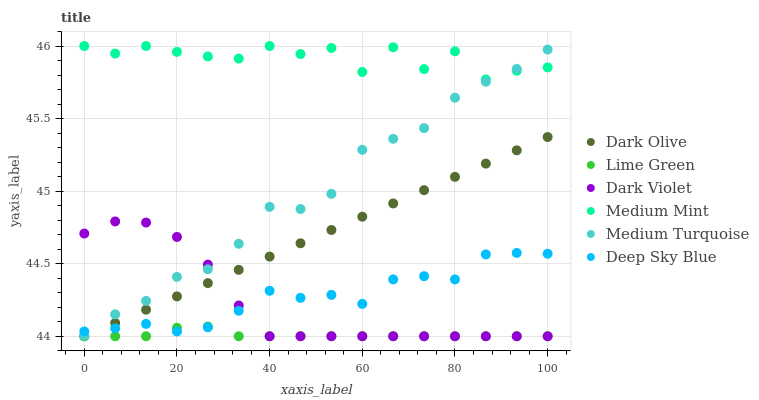Does Lime Green have the minimum area under the curve?
Answer yes or no. Yes. Does Medium Mint have the maximum area under the curve?
Answer yes or no. Yes. Does Medium Turquoise have the minimum area under the curve?
Answer yes or no. No. Does Medium Turquoise have the maximum area under the curve?
Answer yes or no. No. Is Dark Olive the smoothest?
Answer yes or no. Yes. Is Medium Mint the roughest?
Answer yes or no. Yes. Is Medium Turquoise the smoothest?
Answer yes or no. No. Is Medium Turquoise the roughest?
Answer yes or no. No. Does Dark Olive have the lowest value?
Answer yes or no. Yes. Does Medium Turquoise have the lowest value?
Answer yes or no. No. Does Medium Mint have the highest value?
Answer yes or no. Yes. Does Medium Turquoise have the highest value?
Answer yes or no. No. Is Deep Sky Blue less than Medium Mint?
Answer yes or no. Yes. Is Medium Mint greater than Lime Green?
Answer yes or no. Yes. Does Dark Olive intersect Dark Violet?
Answer yes or no. Yes. Is Dark Olive less than Dark Violet?
Answer yes or no. No. Is Dark Olive greater than Dark Violet?
Answer yes or no. No. Does Deep Sky Blue intersect Medium Mint?
Answer yes or no. No. 